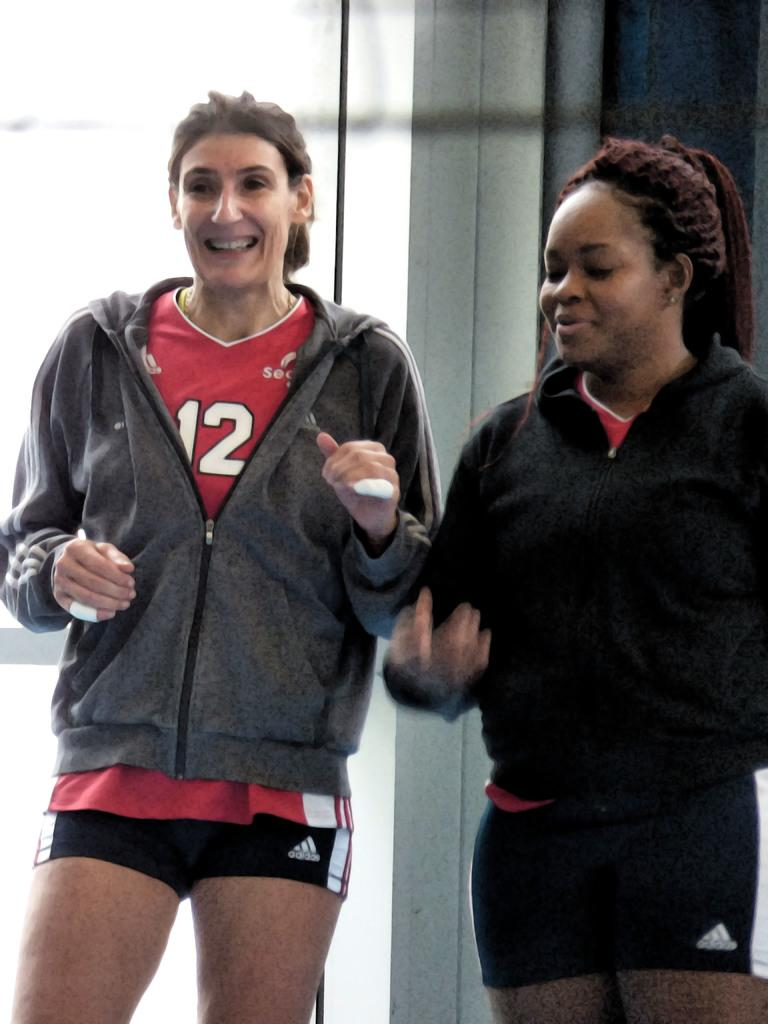Provide a one-sentence caption for the provided image. Two women weaing sports or workout clothing, one of which has a number 12 jersey. 